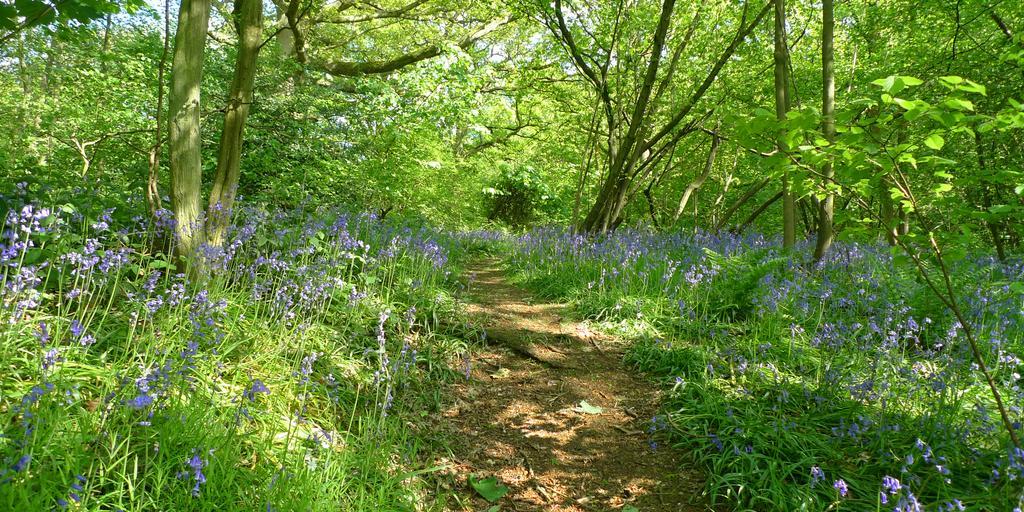How would you summarize this image in a sentence or two? In this image there are trees, there are flowers, there are plants. 